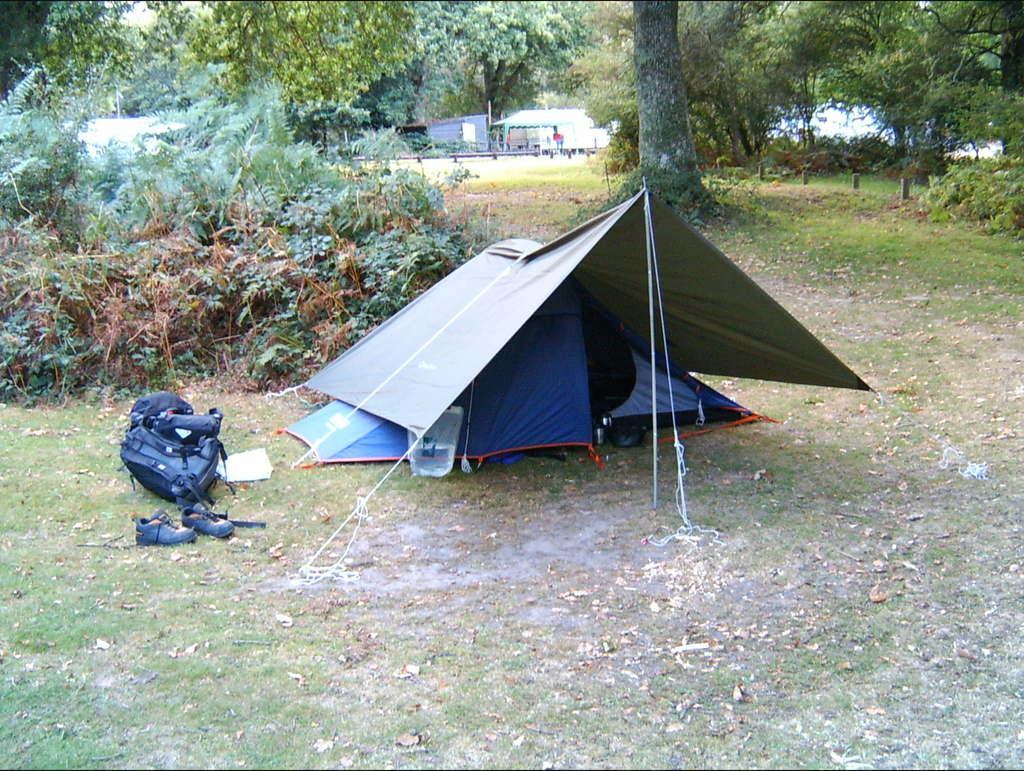Can you describe this image briefly? In this image we can see the tent on the ground and to the side we can see a bag and a pair of shoes. We can see some plants and trees and in the background, we can see some buildings and grass on the ground. 